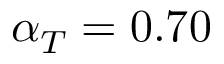<formula> <loc_0><loc_0><loc_500><loc_500>\alpha _ { T } = 0 . 7 0</formula> 